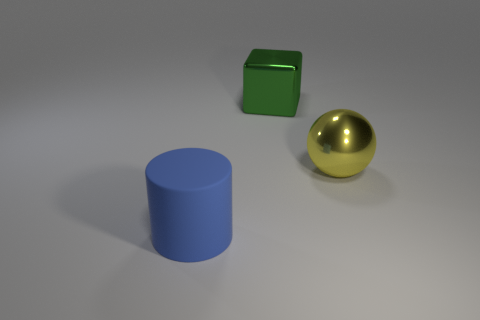Add 1 spheres. How many objects exist? 4 Subtract all cubes. How many objects are left? 2 Subtract all green balls. How many cyan cylinders are left? 0 Subtract all large metallic things. Subtract all large blue rubber things. How many objects are left? 0 Add 3 large green metal things. How many large green metal things are left? 4 Add 2 blocks. How many blocks exist? 3 Subtract 0 purple cylinders. How many objects are left? 3 